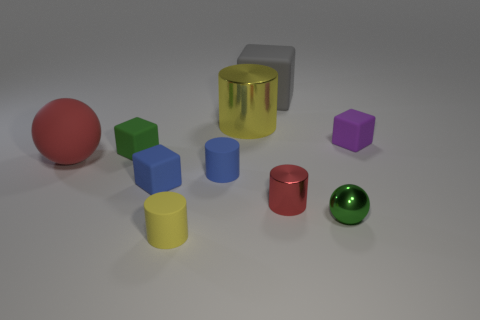Are the small purple object and the red object that is to the right of the large yellow metal cylinder made of the same material?
Your response must be concise. No. There is a matte cube right of the small red metal thing; does it have the same color as the large cube?
Make the answer very short. No. What material is the small cube that is both right of the green cube and left of the tiny purple matte thing?
Your answer should be compact. Rubber. The blue cylinder has what size?
Provide a short and direct response. Small. Does the large metal cylinder have the same color as the tiny block in front of the large red object?
Your response must be concise. No. How many other objects are the same color as the large cylinder?
Your answer should be very brief. 1. There is a red thing right of the gray matte block; does it have the same size as the sphere to the left of the blue matte cylinder?
Ensure brevity in your answer.  No. There is a big matte object that is in front of the tiny purple rubber cube; what is its color?
Provide a short and direct response. Red. Is the number of small blue things behind the gray matte cube less than the number of large matte things?
Offer a very short reply. Yes. Do the big block and the blue cube have the same material?
Your response must be concise. Yes. 